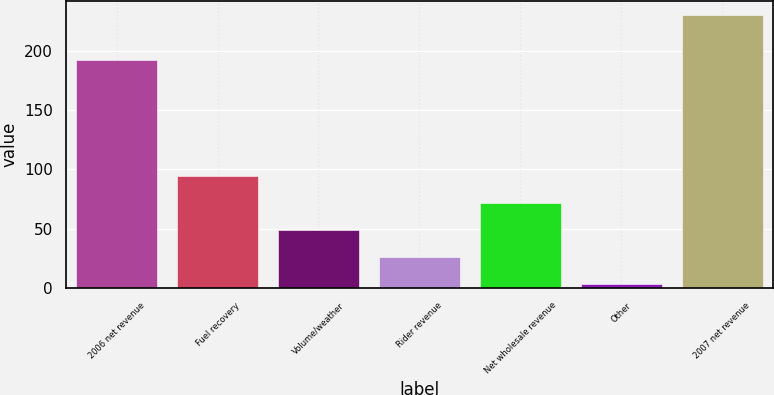<chart> <loc_0><loc_0><loc_500><loc_500><bar_chart><fcel>2006 net revenue<fcel>Fuel recovery<fcel>Volume/weather<fcel>Rider revenue<fcel>Net wholesale revenue<fcel>Other<fcel>2007 net revenue<nl><fcel>192.2<fcel>94.38<fcel>48.84<fcel>26.07<fcel>71.61<fcel>3.3<fcel>231<nl></chart> 